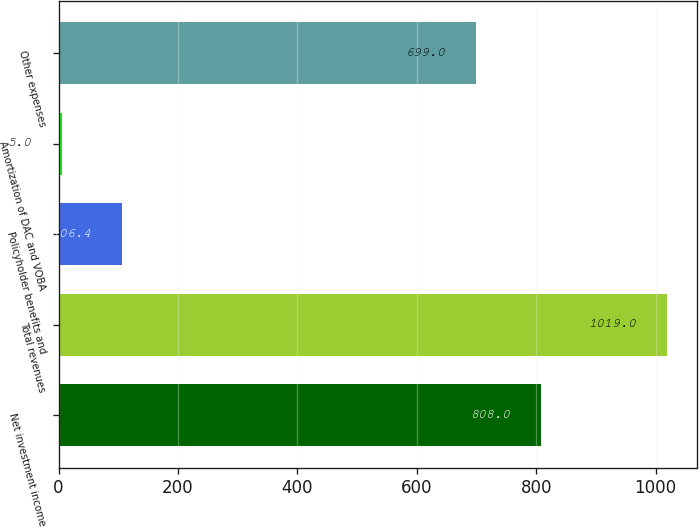Convert chart to OTSL. <chart><loc_0><loc_0><loc_500><loc_500><bar_chart><fcel>Net investment income<fcel>Total revenues<fcel>Policyholder benefits and<fcel>Amortization of DAC and VOBA<fcel>Other expenses<nl><fcel>808<fcel>1019<fcel>106.4<fcel>5<fcel>699<nl></chart> 